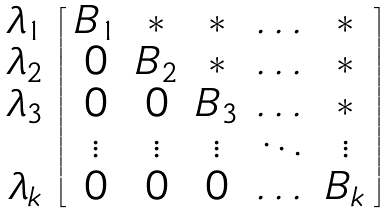<formula> <loc_0><loc_0><loc_500><loc_500>\begin{array} { c } \lambda _ { 1 } \\ \lambda _ { 2 } \\ \lambda _ { 3 } \\ \\ \lambda _ { k } \\ \end{array} \left [ \begin{array} { c c c c c } B _ { 1 } & * & * & \dots & * \\ 0 & B _ { 2 } & * & \dots & * \\ 0 & 0 & B _ { 3 } & \dots & * \\ \vdots & \vdots & \vdots & \ddots & \vdots \\ 0 & 0 & 0 & \dots & B _ { k } \\ \end{array} \right ]</formula> 